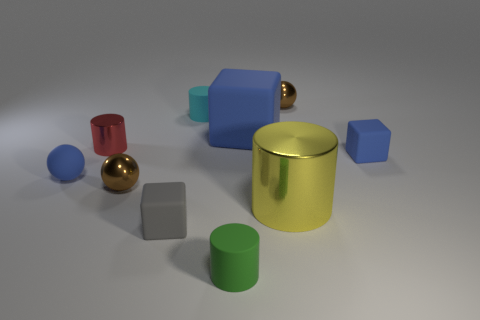Subtract all large yellow shiny cylinders. How many cylinders are left? 3 Subtract all green cylinders. How many blue blocks are left? 2 Subtract all gray cubes. How many cubes are left? 2 Subtract 1 blocks. How many blocks are left? 2 Subtract all cubes. How many objects are left? 7 Subtract all big matte objects. Subtract all big matte blocks. How many objects are left? 8 Add 9 small blue matte blocks. How many small blue matte blocks are left? 10 Add 1 small blue blocks. How many small blue blocks exist? 2 Subtract 1 blue blocks. How many objects are left? 9 Subtract all brown balls. Subtract all cyan cylinders. How many balls are left? 1 